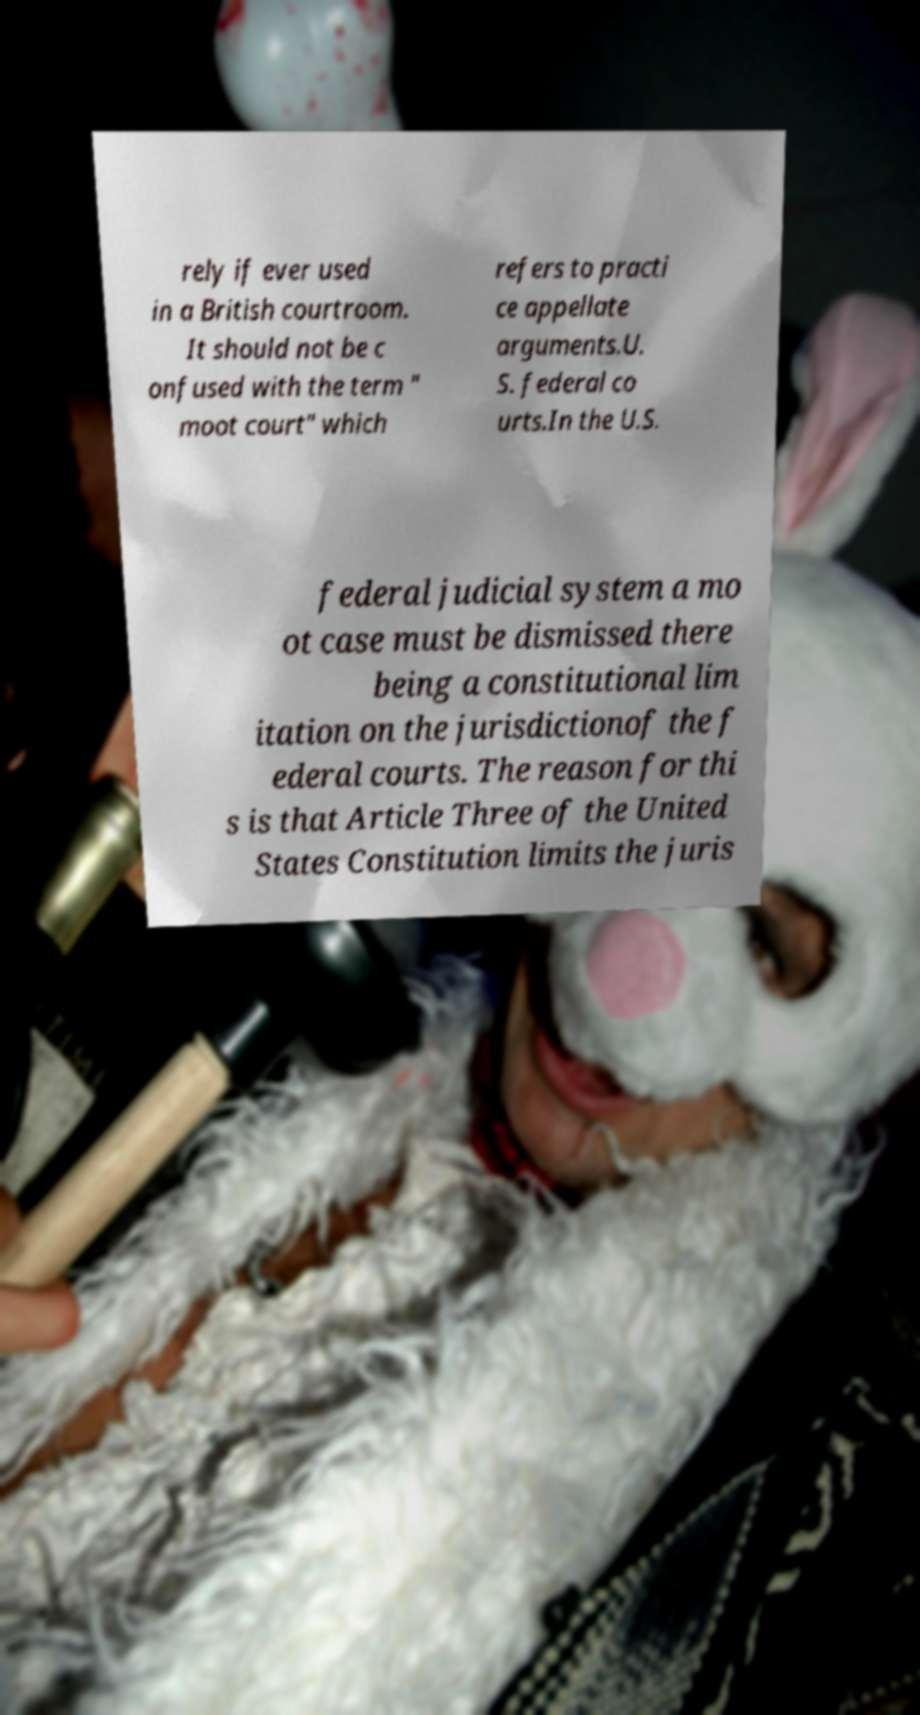Can you read and provide the text displayed in the image?This photo seems to have some interesting text. Can you extract and type it out for me? rely if ever used in a British courtroom. It should not be c onfused with the term " moot court" which refers to practi ce appellate arguments.U. S. federal co urts.In the U.S. federal judicial system a mo ot case must be dismissed there being a constitutional lim itation on the jurisdictionof the f ederal courts. The reason for thi s is that Article Three of the United States Constitution limits the juris 